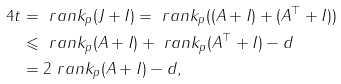<formula> <loc_0><loc_0><loc_500><loc_500>4 t & = \ r a n k _ { p } ( J + I ) = \ r a n k _ { p } ( ( A + I ) + ( A ^ { \top } + I ) ) \\ & \leqslant \ r a n k _ { p } ( A + I ) + \ r a n k _ { p } ( A ^ { \top } + I ) - d \\ & = 2 \ r a n k _ { p } ( A + I ) - d ,</formula> 